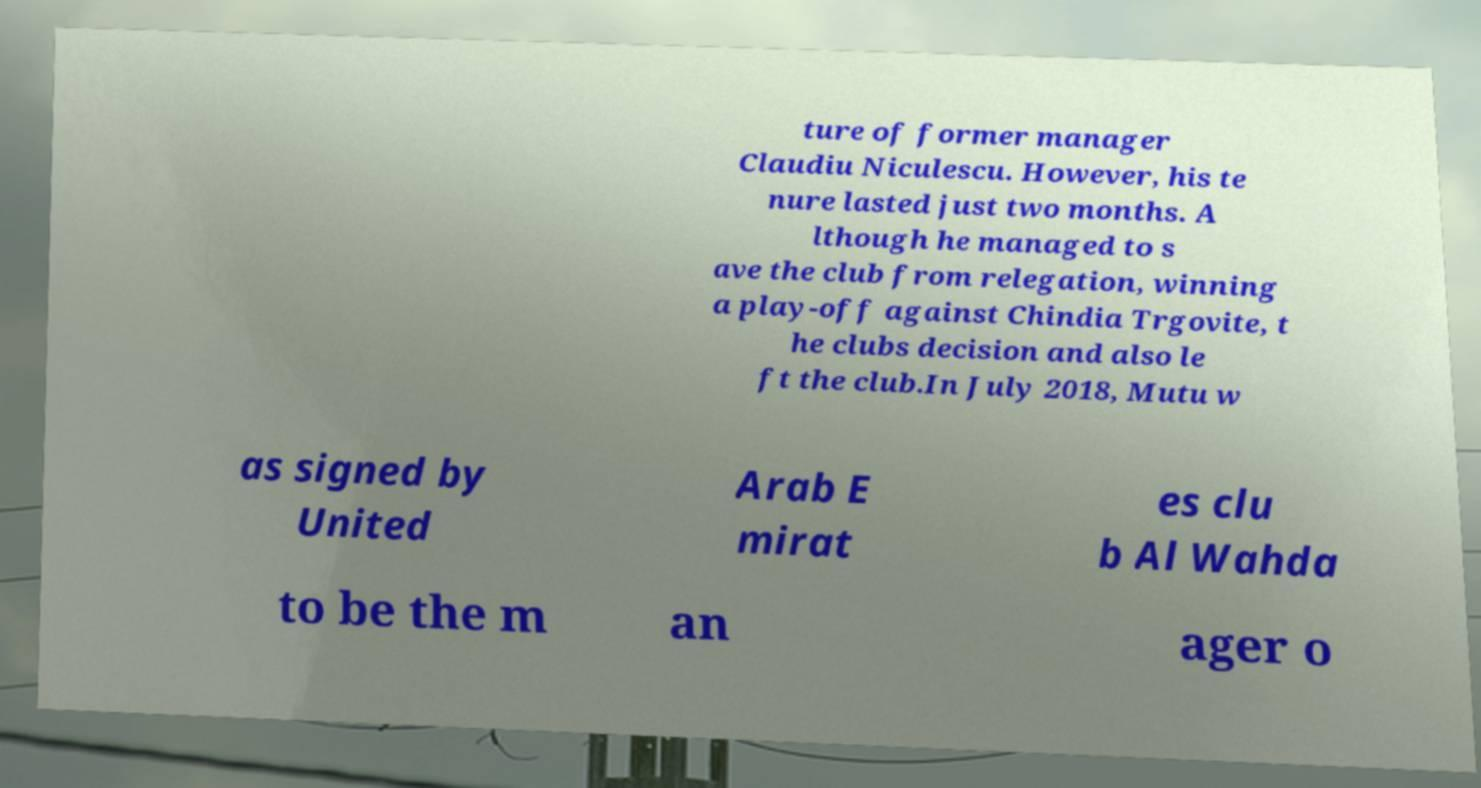There's text embedded in this image that I need extracted. Can you transcribe it verbatim? ture of former manager Claudiu Niculescu. However, his te nure lasted just two months. A lthough he managed to s ave the club from relegation, winning a play-off against Chindia Trgovite, t he clubs decision and also le ft the club.In July 2018, Mutu w as signed by United Arab E mirat es clu b Al Wahda to be the m an ager o 